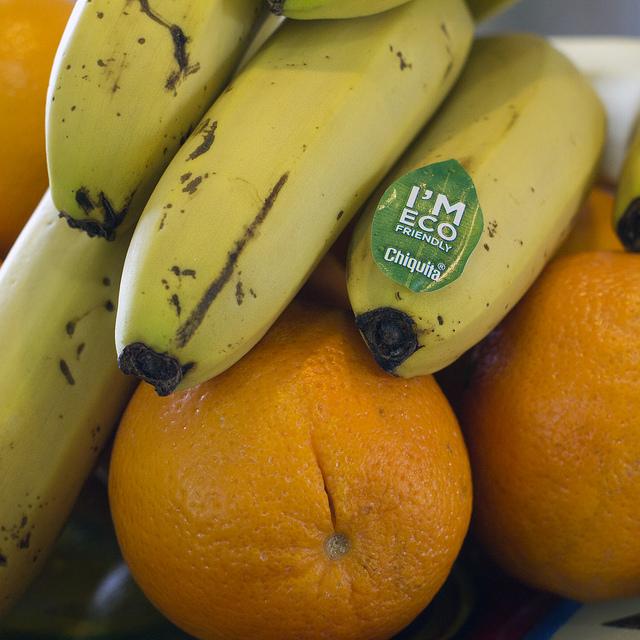What color is the brand sticker?
Keep it brief. Green. What is the brand on the bananas?
Answer briefly. Chiquita. What company grows these bananas?
Concise answer only. Chiquita. How many bananas can be seen?
Concise answer only. 5. What other fruit is here?
Be succinct. Bananas and oranges. Are the bananas hanging?
Quick response, please. No. What brand are these bananas?
Be succinct. Chiquita. 